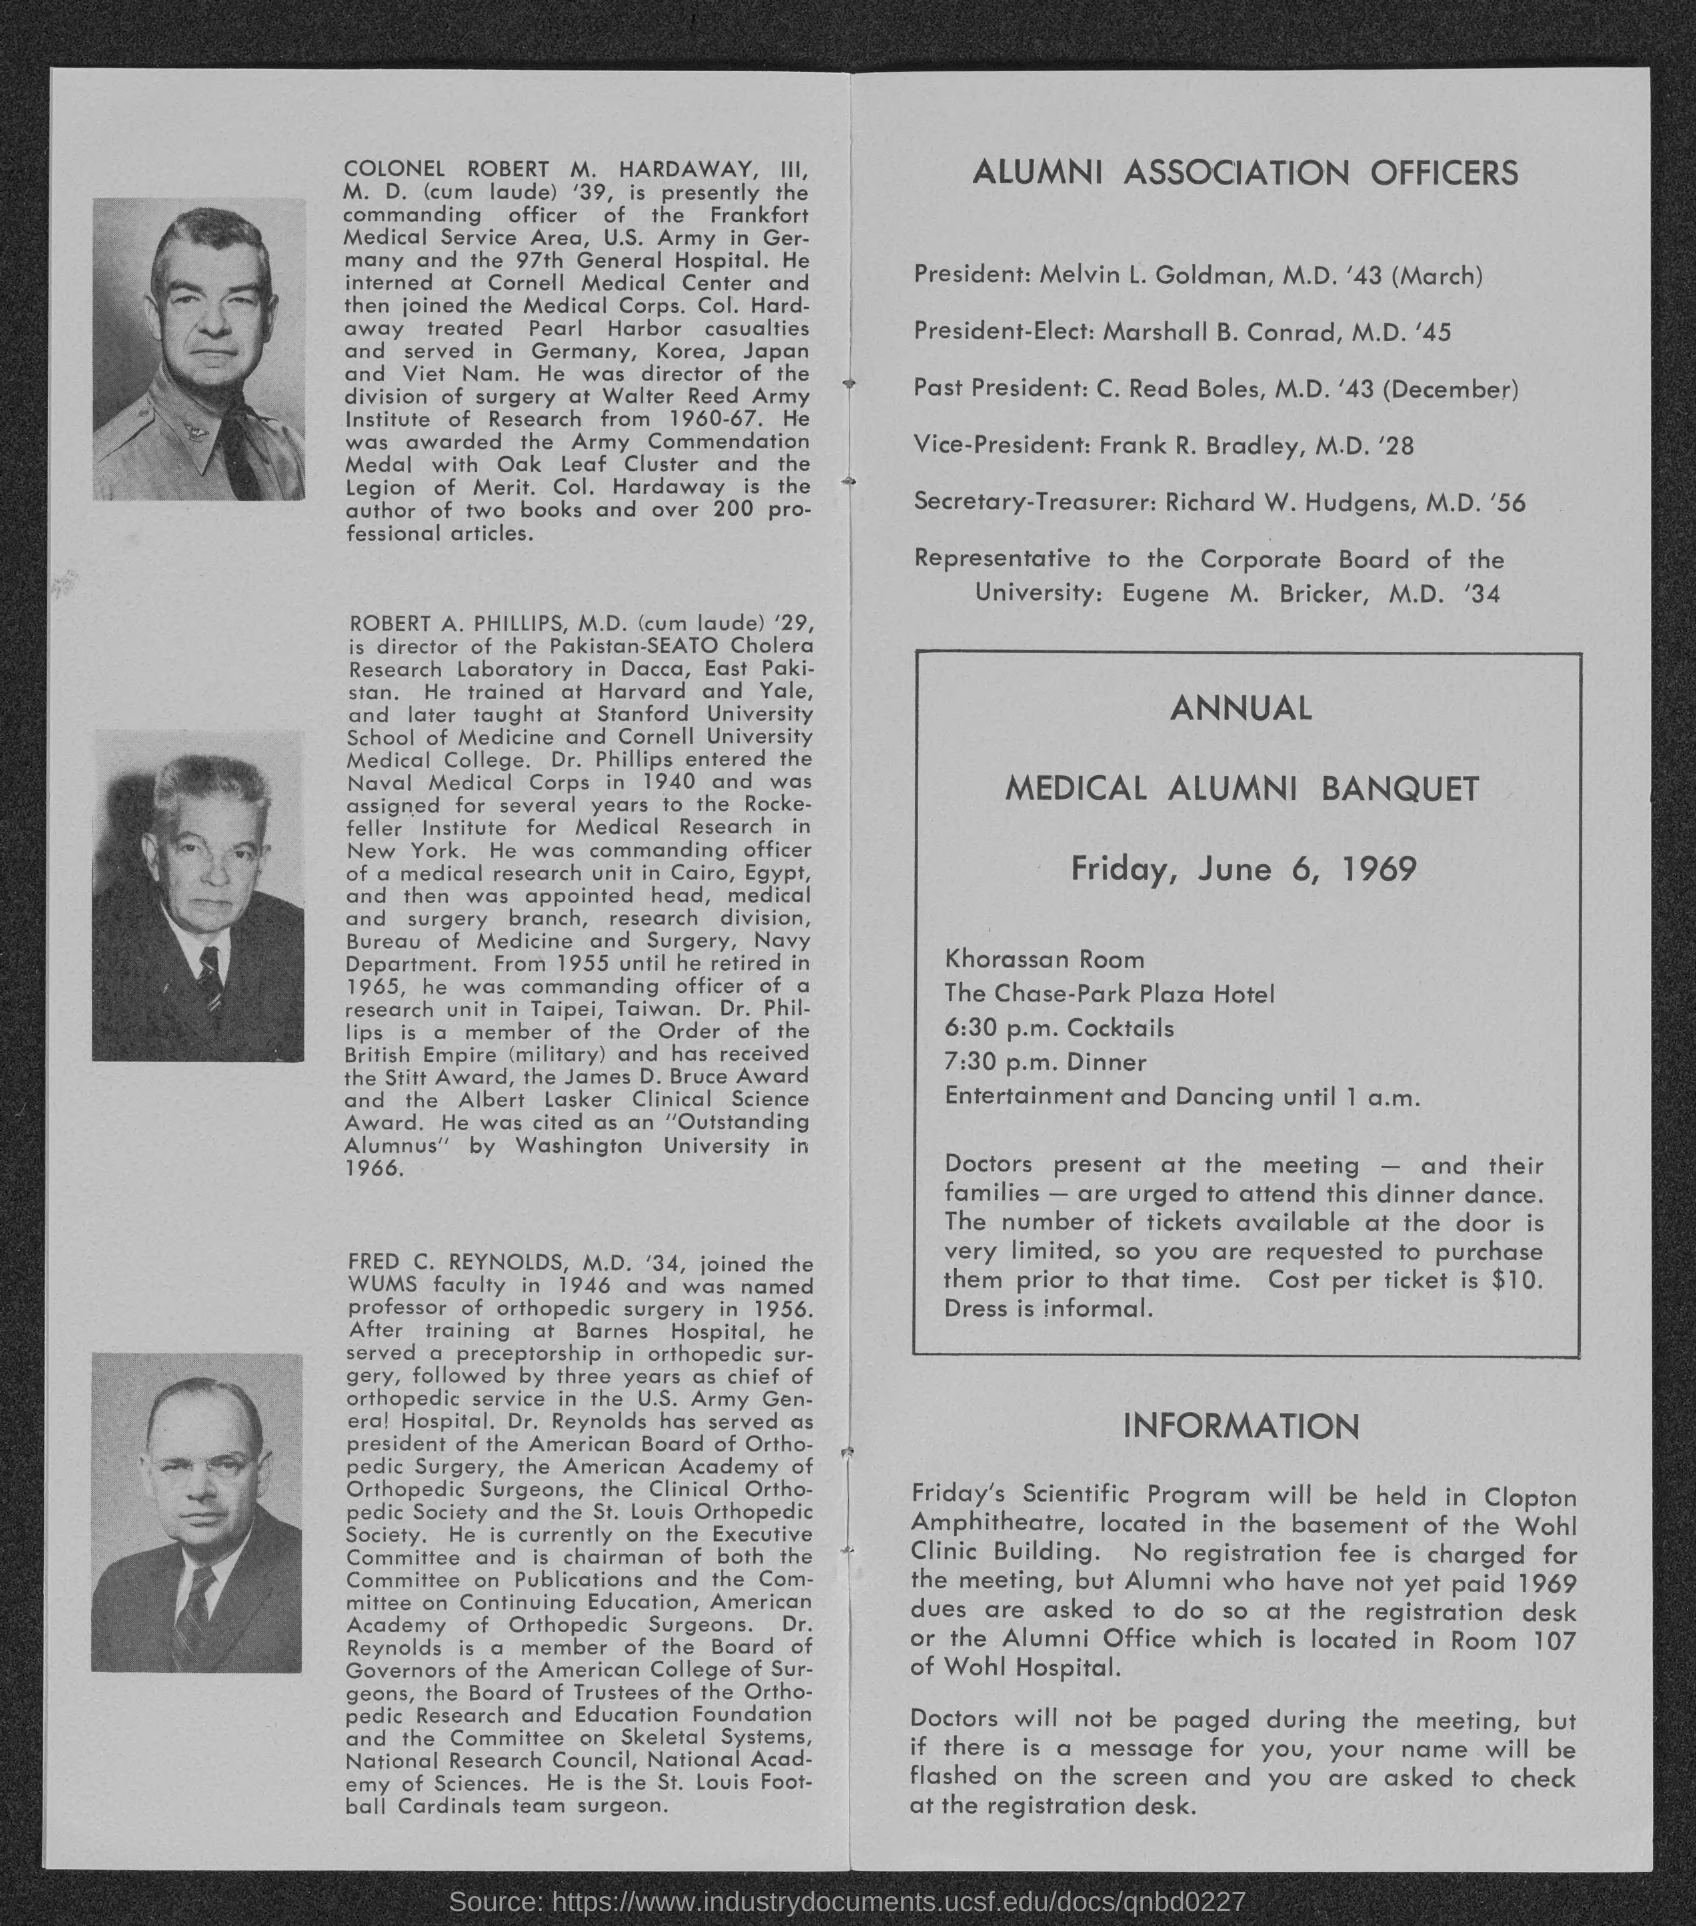Specify some key components in this picture. Melvin L. Goldman is the president. Frank R. Bradley holds the position of Vice-President. C. Read Boles is the past president. Marshall B. Conrad holds the position of President-Elect. 